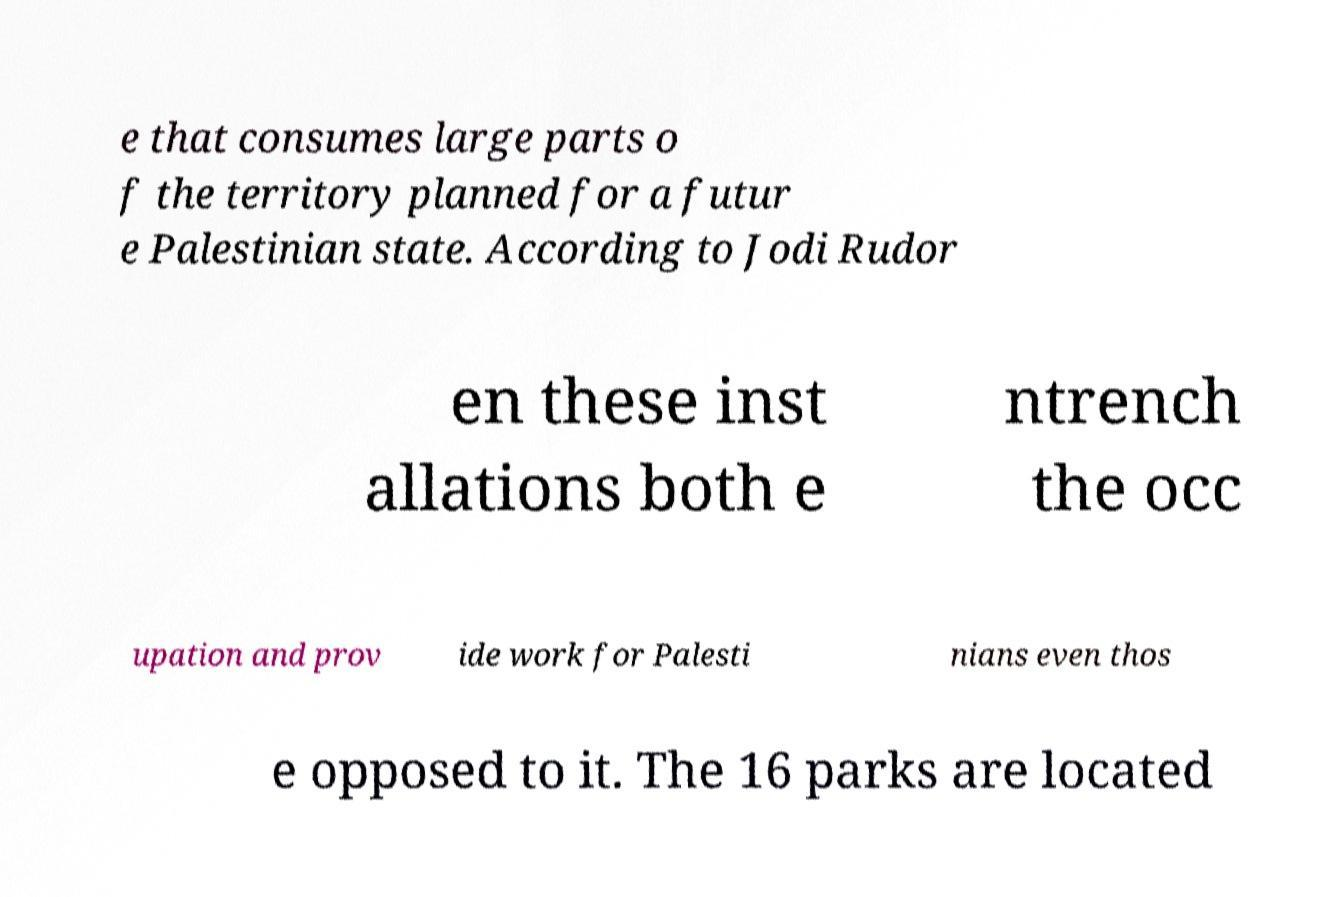I need the written content from this picture converted into text. Can you do that? e that consumes large parts o f the territory planned for a futur e Palestinian state. According to Jodi Rudor en these inst allations both e ntrench the occ upation and prov ide work for Palesti nians even thos e opposed to it. The 16 parks are located 